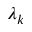<formula> <loc_0><loc_0><loc_500><loc_500>\lambda _ { k }</formula> 